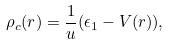<formula> <loc_0><loc_0><loc_500><loc_500>\rho _ { c } ( r ) = \frac { 1 } { u } ( \epsilon _ { 1 } - V ( r ) ) ,</formula> 